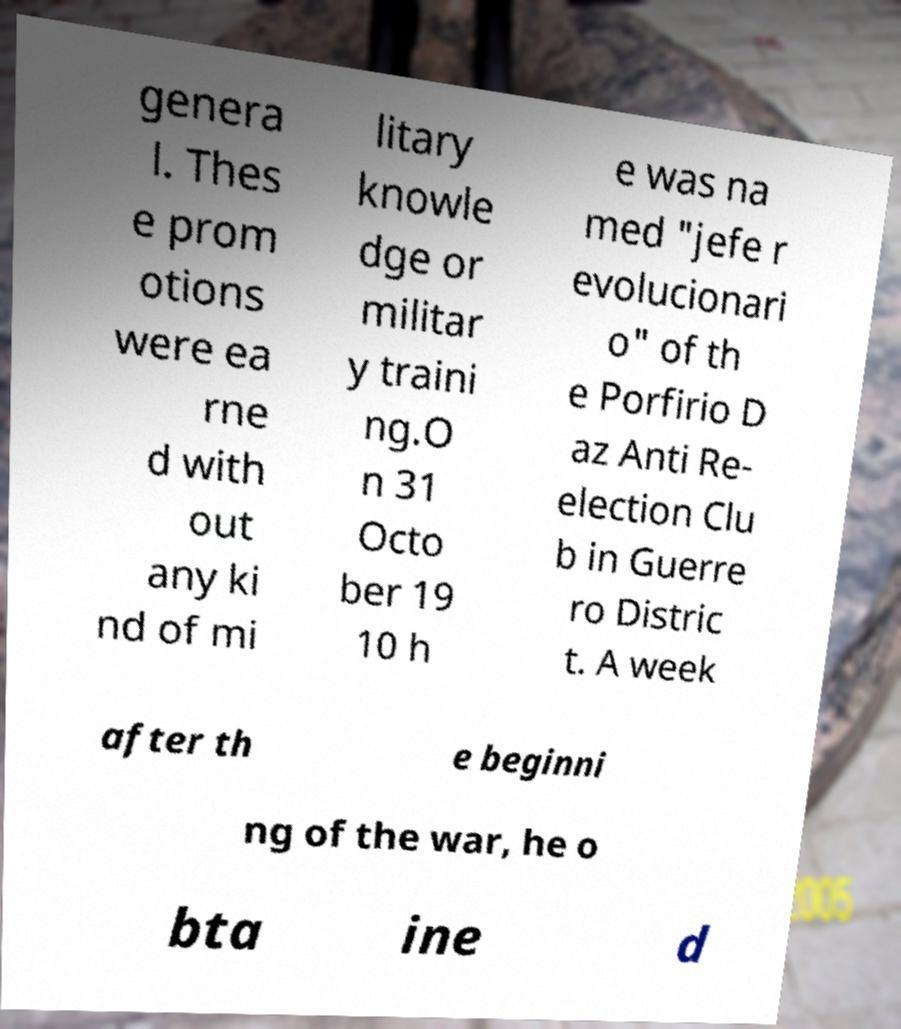For documentation purposes, I need the text within this image transcribed. Could you provide that? genera l. Thes e prom otions were ea rne d with out any ki nd of mi litary knowle dge or militar y traini ng.O n 31 Octo ber 19 10 h e was na med "jefe r evolucionari o" of th e Porfirio D az Anti Re- election Clu b in Guerre ro Distric t. A week after th e beginni ng of the war, he o bta ine d 